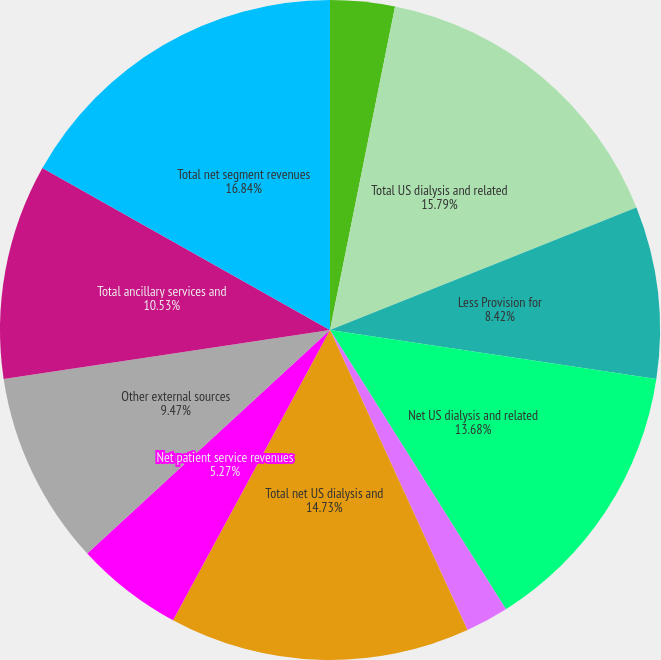Convert chart to OTSL. <chart><loc_0><loc_0><loc_500><loc_500><pie_chart><fcel>Intersegment revenues<fcel>Total US dialysis and related<fcel>Less Provision for<fcel>Net US dialysis and related<fcel>Other revenues (1)<fcel>Total net US dialysis and<fcel>Net patient service revenues<fcel>Other external sources<fcel>Total ancillary services and<fcel>Total net segment revenues<nl><fcel>3.16%<fcel>15.79%<fcel>8.42%<fcel>13.68%<fcel>2.11%<fcel>14.73%<fcel>5.27%<fcel>9.47%<fcel>10.53%<fcel>16.84%<nl></chart> 